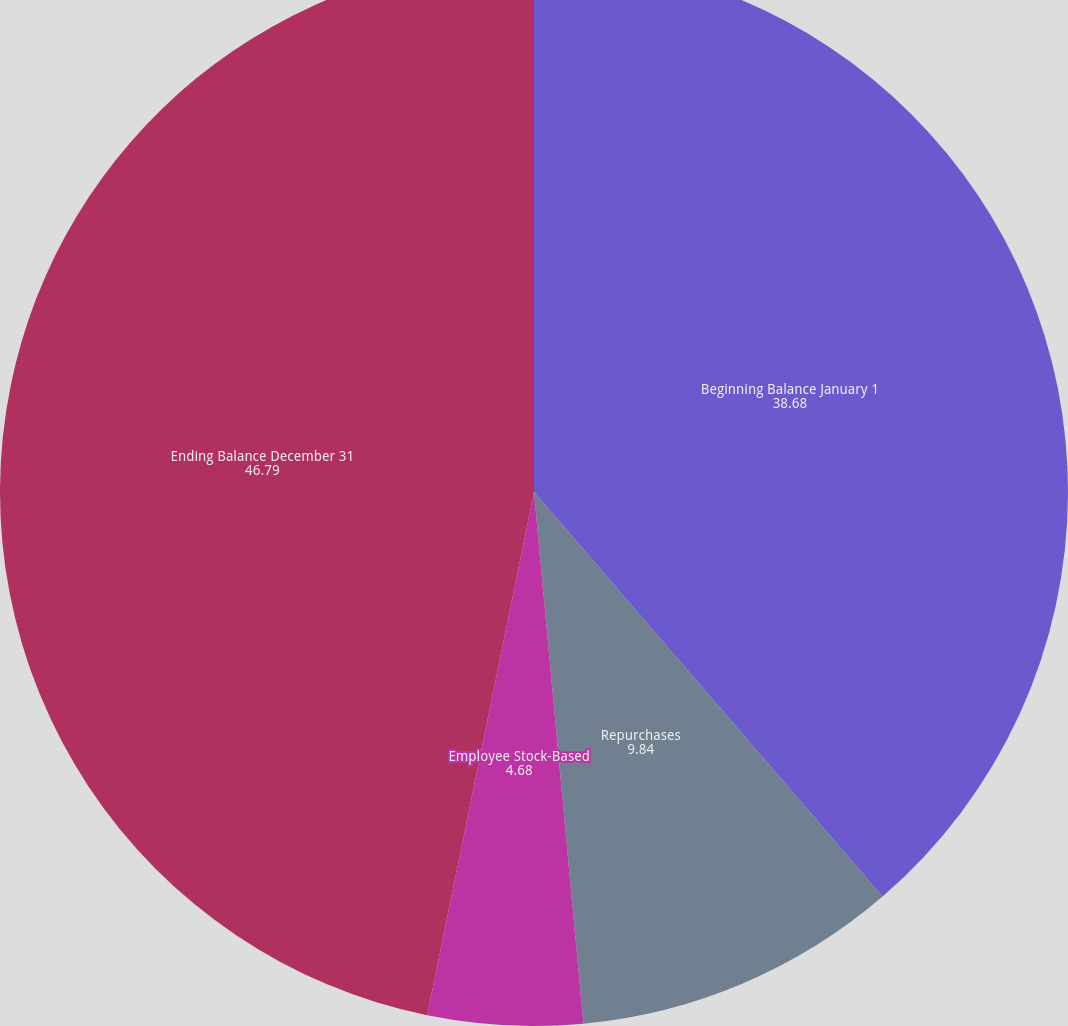Convert chart. <chart><loc_0><loc_0><loc_500><loc_500><pie_chart><fcel>Beginning Balance January 1<fcel>Repurchases<fcel>Employee Stock-Based<fcel>Directors' Plan<fcel>Ending Balance December 31<nl><fcel>38.68%<fcel>9.84%<fcel>4.68%<fcel>0.0%<fcel>46.79%<nl></chart> 